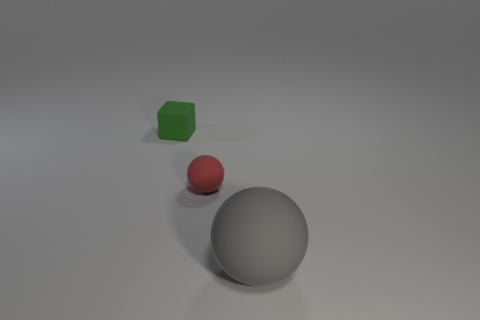Add 2 tiny yellow cylinders. How many objects exist? 5 Subtract all balls. How many objects are left? 1 Subtract all red blocks. Subtract all red cylinders. How many blocks are left? 1 Subtract all large rubber objects. Subtract all red matte spheres. How many objects are left? 1 Add 1 small green blocks. How many small green blocks are left? 2 Add 2 large yellow rubber objects. How many large yellow rubber objects exist? 2 Subtract all gray balls. How many balls are left? 1 Subtract 0 cyan cubes. How many objects are left? 3 Subtract 2 balls. How many balls are left? 0 